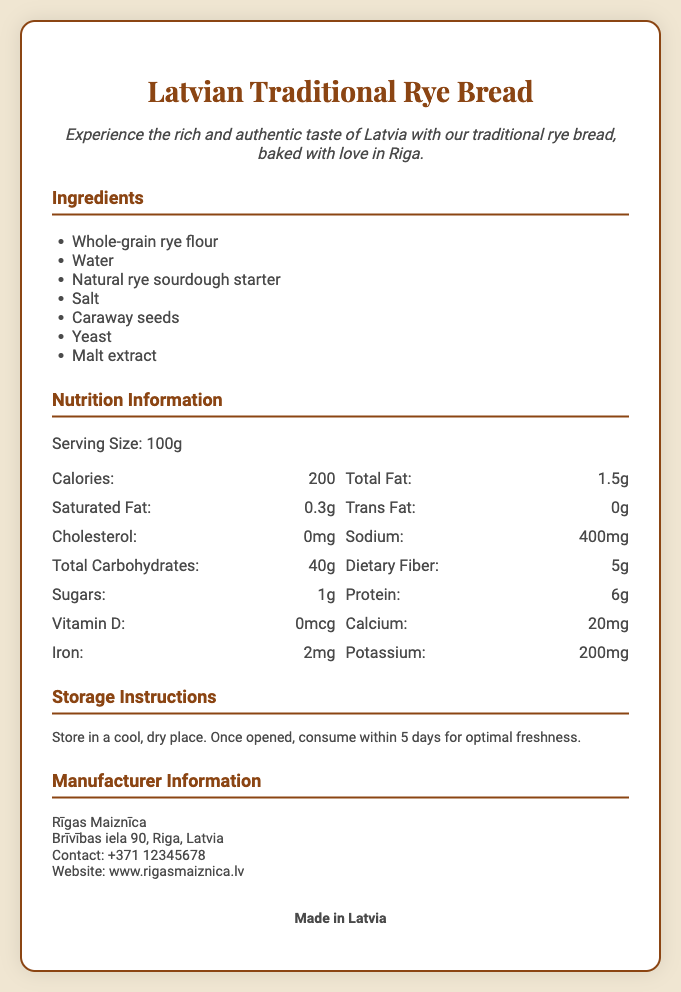What is the serving size? The serving size is specified in the Nutrition Information section of the document.
Answer: 100g What is the main ingredient in the bread? The first ingredient listed in the Ingredients section is the primary component of the product.
Answer: Whole-grain rye flour How much protein is in a serving? The amount of protein is provided in the Nutrition Information grid.
Answer: 6g What are the storage instructions? The Storage Instructions section provides guidance on how to keep the bread fresh.
Answer: Store in a cool, dry place Who is the manufacturer? The Manufacturer Information section identifies the company responsible for the product.
Answer: Rīgas Maiznīca What is the sodium content? The sodium content is listed in the Nutrition Information grid.
Answer: 400mg Where is the product made? The document specifies the origin of the bread at the end.
Answer: Made in Latvia What is the caloric value per serving? The total calorie information is provided in the Nutrition Information section.
Answer: 200 How long should the bread be consumed after opening? The Storage Instructions provide specific details on consumption after opening.
Answer: 5 days 